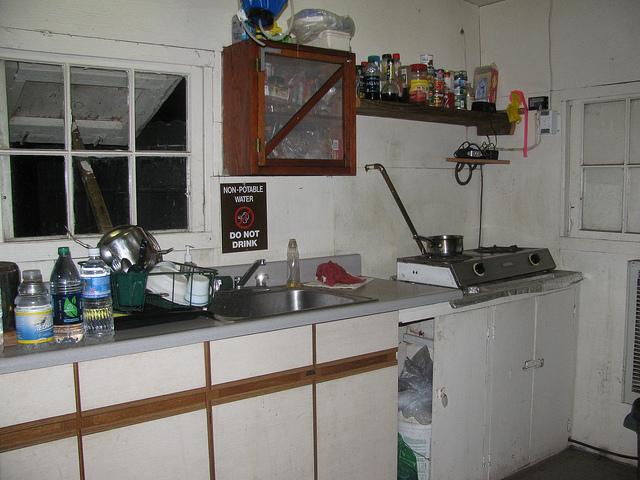Is this a photo shoot?
Keep it brief. No. How many bottles are there on the counter?
Concise answer only. 3. Is this a tidy kitchen?
Answer briefly. No. What color are the cabinets?
Write a very short answer. White. What color is the bottle on the counter?
Be succinct. Clear. How many panes are in the window?
Write a very short answer. 6. Is daylight visible through the window?
Keep it brief. No. Is this room clean?
Write a very short answer. No. What is in the bottles on the counter?
Quick response, please. Water. Where is the light in the room coming from?
Concise answer only. Light bulb. How many bottles are on the counter?
Answer briefly. 3. Is this kitchen neat?
Quick response, please. No. 